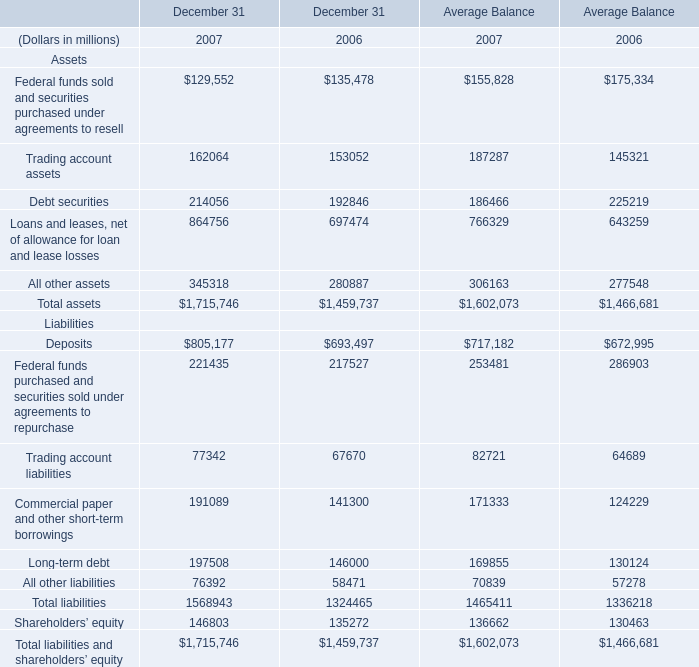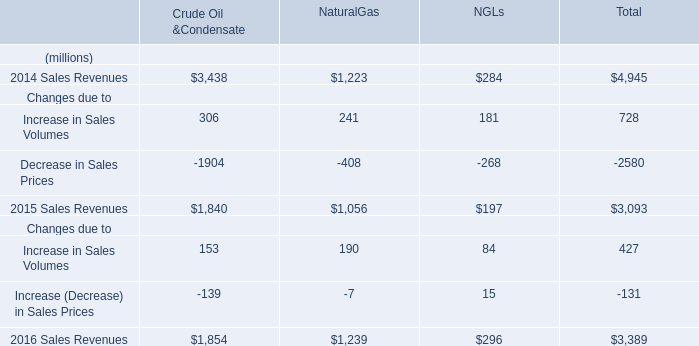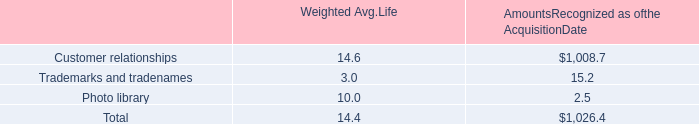What will Average Balance for Total assets reach in 2008 if it continues to grow at its current rate? (in million) 
Computations: (1602073 * (1 + ((1602073 - 1466681) / 1466681)))
Answer: 1749963.28263. 